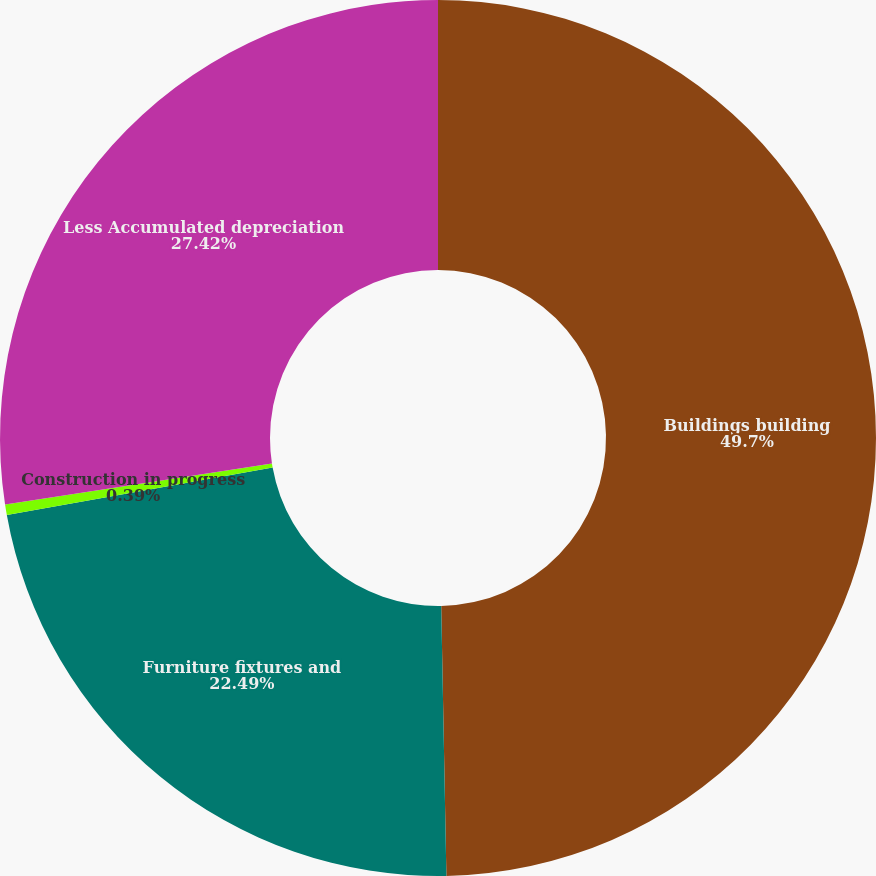Convert chart. <chart><loc_0><loc_0><loc_500><loc_500><pie_chart><fcel>Buildings building<fcel>Furniture fixtures and<fcel>Construction in progress<fcel>Less Accumulated depreciation<nl><fcel>49.69%<fcel>22.49%<fcel>0.39%<fcel>27.42%<nl></chart> 